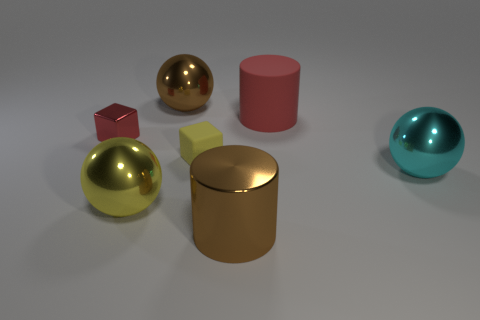Subtract all brown cylinders. How many cylinders are left? 1 Subtract 1 cylinders. How many cylinders are left? 1 Subtract all balls. How many objects are left? 4 Subtract all purple blocks. How many red cylinders are left? 1 Add 1 cylinders. How many cylinders are left? 3 Add 7 tiny yellow rubber blocks. How many tiny yellow rubber blocks exist? 8 Add 1 big red cubes. How many objects exist? 8 Subtract 0 brown cubes. How many objects are left? 7 Subtract all brown balls. Subtract all red blocks. How many balls are left? 2 Subtract all small purple matte objects. Subtract all large brown shiny cylinders. How many objects are left? 6 